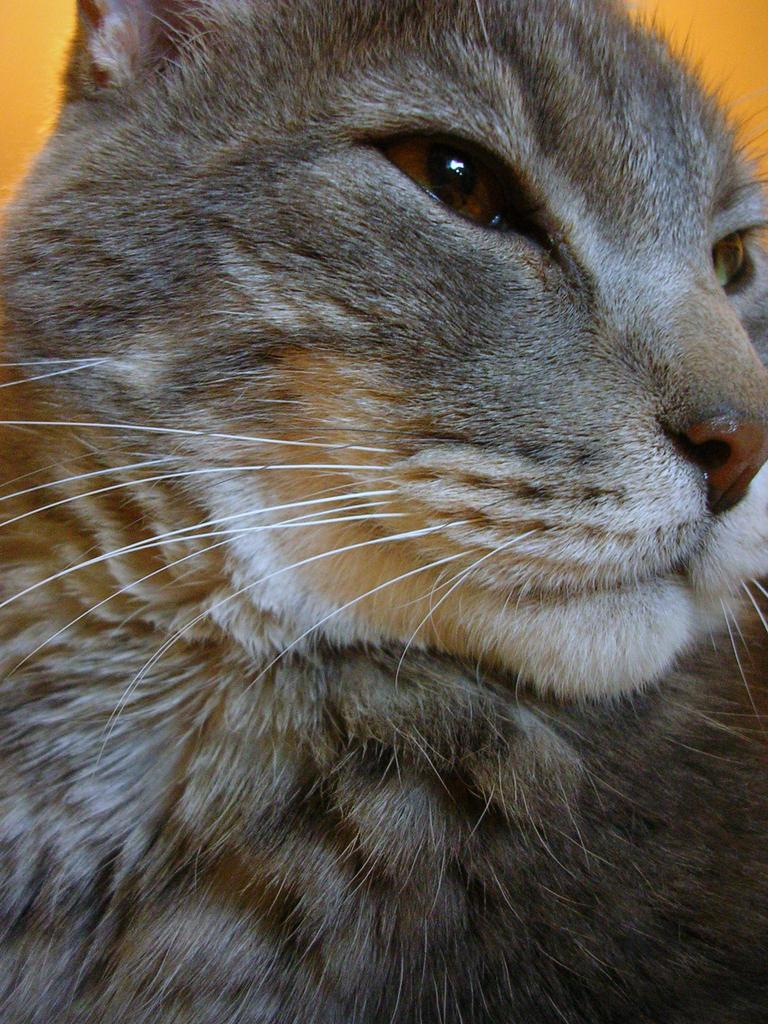What type of animal is in the image? There is a cat in the image. Can you describe the color of the cat? The cat is brown in color. How many dinosaurs can be seen in the image? There are no dinosaurs present in the image. What type of body is visible in the image? The image only features a cat, and there is no indication of any other body. 